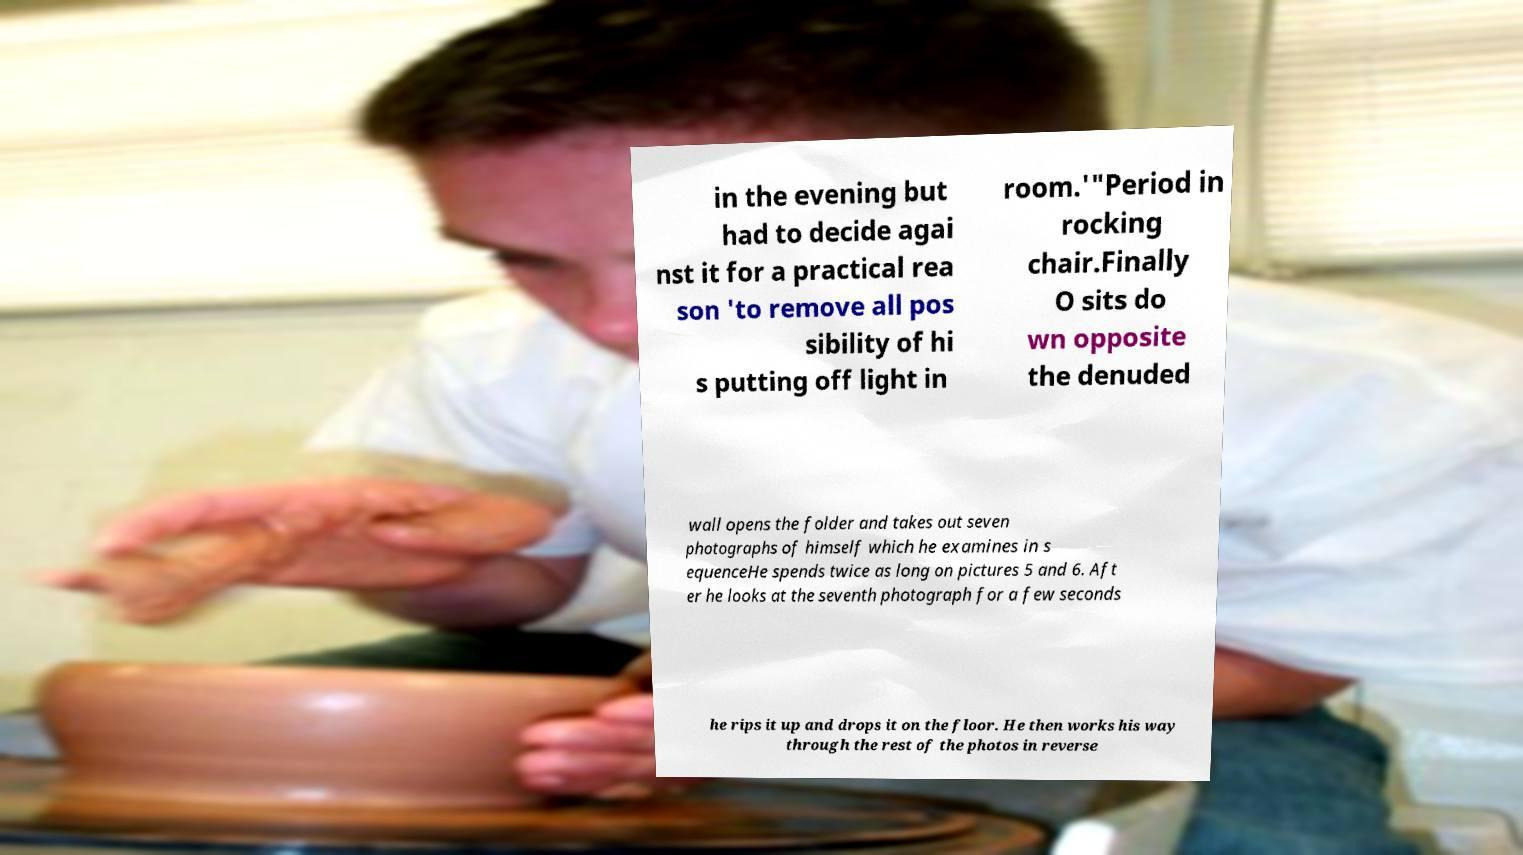Could you extract and type out the text from this image? in the evening but had to decide agai nst it for a practical rea son 'to remove all pos sibility of hi s putting off light in room.'"Period in rocking chair.Finally O sits do wn opposite the denuded wall opens the folder and takes out seven photographs of himself which he examines in s equenceHe spends twice as long on pictures 5 and 6. Aft er he looks at the seventh photograph for a few seconds he rips it up and drops it on the floor. He then works his way through the rest of the photos in reverse 